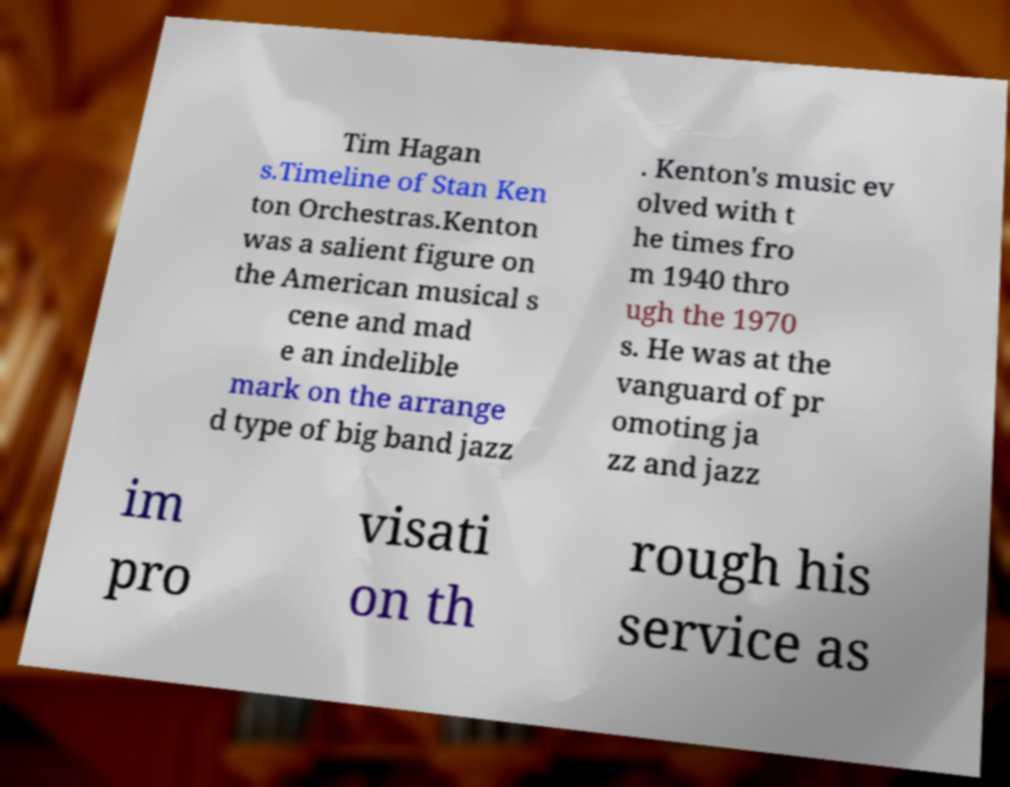Please identify and transcribe the text found in this image. Tim Hagan s.Timeline of Stan Ken ton Orchestras.Kenton was a salient figure on the American musical s cene and mad e an indelible mark on the arrange d type of big band jazz . Kenton's music ev olved with t he times fro m 1940 thro ugh the 1970 s. He was at the vanguard of pr omoting ja zz and jazz im pro visati on th rough his service as 